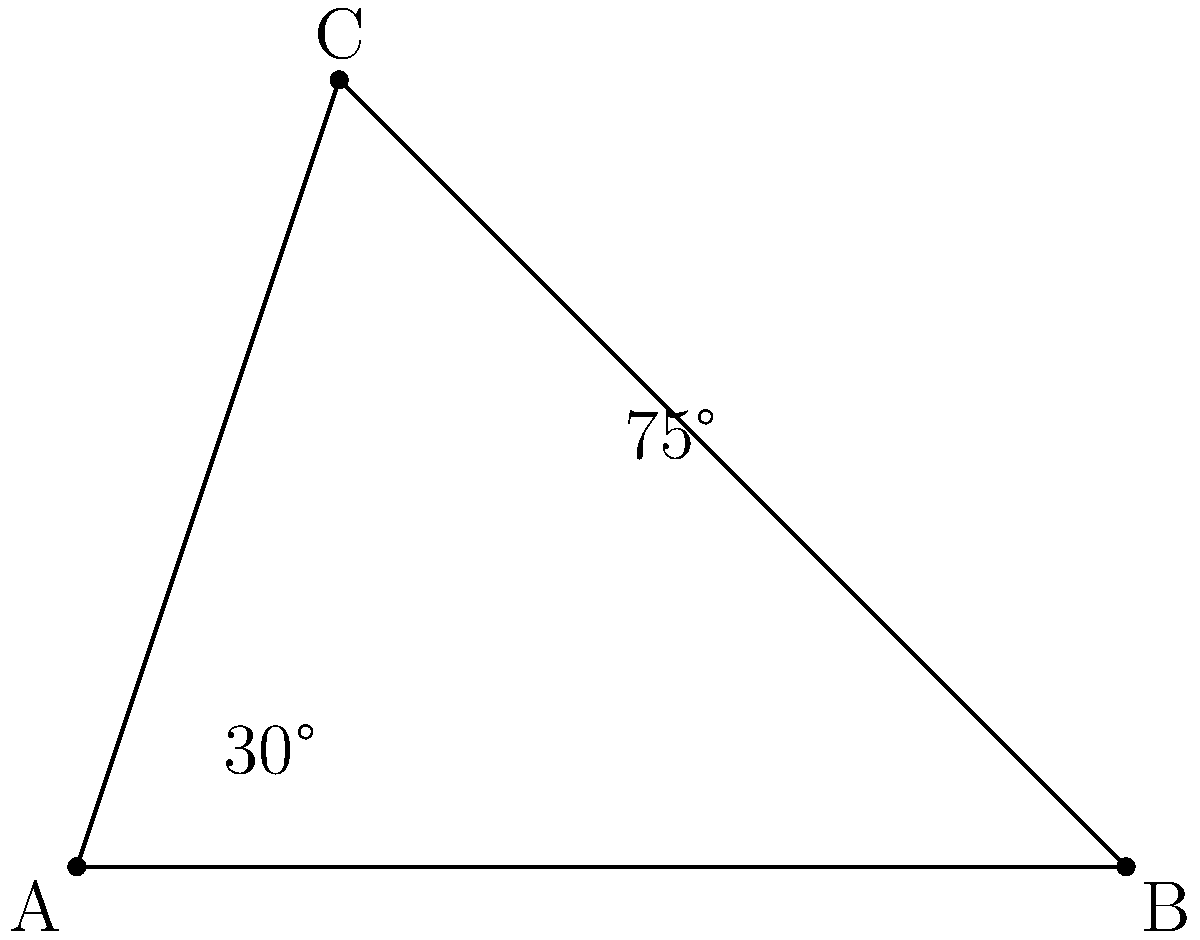On a medieval map of the Silk Road, two major trade routes intersect at point C. One route runs from A to B, while the other runs from A to C. If the angle between AC and AB is 30°, and the angle between BC and AC is 75°, what is the measure of angle ABC? To solve this problem, we'll use the properties of triangles:

1. In any triangle, the sum of all interior angles is always 180°.

2. We are given two angles in the triangle:
   - Angle CAB = 30°
   - Angle BCA = 75°

3. Let's call the angle we're looking for (angle ABC) as x°.

4. We can set up an equation based on the fact that all angles in a triangle sum to 180°:
   
   $30° + 75° + x° = 180°$

5. Simplify:
   
   $105° + x° = 180°$

6. Subtract 105° from both sides:
   
   $x° = 180° - 105°$
   $x° = 75°$

Therefore, the measure of angle ABC is 75°.
Answer: 75° 